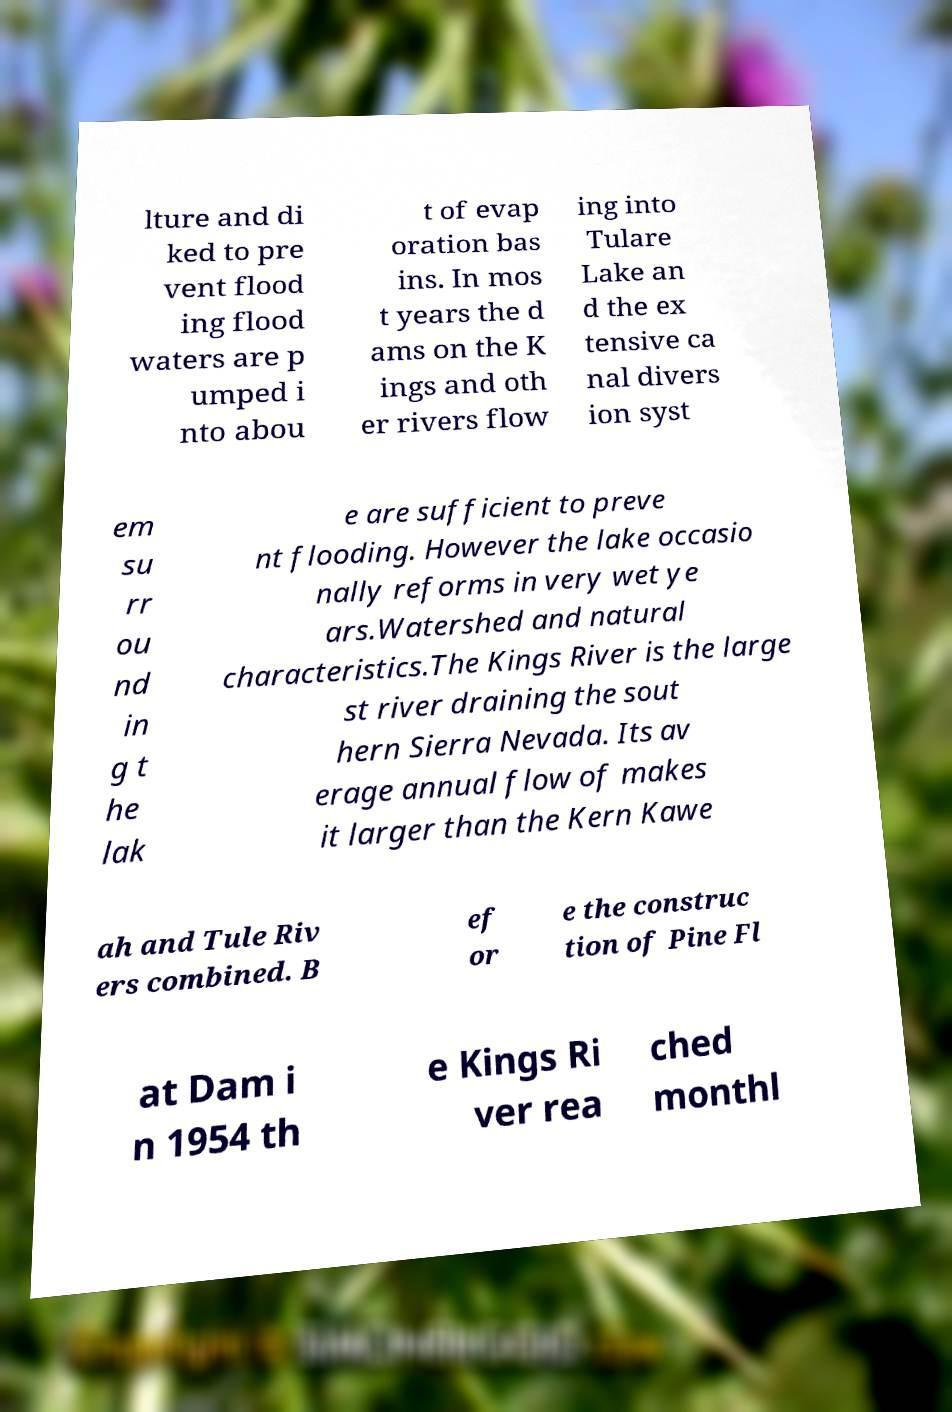Please read and relay the text visible in this image. What does it say? lture and di ked to pre vent flood ing flood waters are p umped i nto abou t of evap oration bas ins. In mos t years the d ams on the K ings and oth er rivers flow ing into Tulare Lake an d the ex tensive ca nal divers ion syst em su rr ou nd in g t he lak e are sufficient to preve nt flooding. However the lake occasio nally reforms in very wet ye ars.Watershed and natural characteristics.The Kings River is the large st river draining the sout hern Sierra Nevada. Its av erage annual flow of makes it larger than the Kern Kawe ah and Tule Riv ers combined. B ef or e the construc tion of Pine Fl at Dam i n 1954 th e Kings Ri ver rea ched monthl 